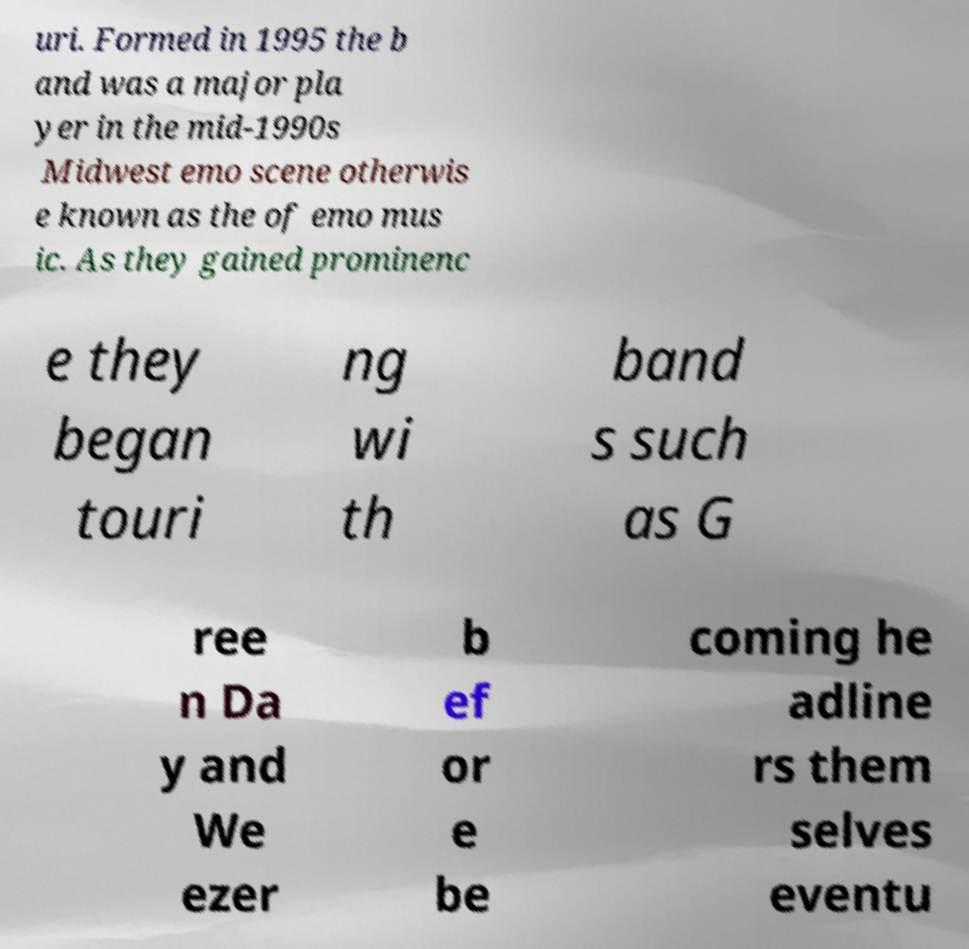What messages or text are displayed in this image? I need them in a readable, typed format. uri. Formed in 1995 the b and was a major pla yer in the mid-1990s Midwest emo scene otherwis e known as the of emo mus ic. As they gained prominenc e they began touri ng wi th band s such as G ree n Da y and We ezer b ef or e be coming he adline rs them selves eventu 